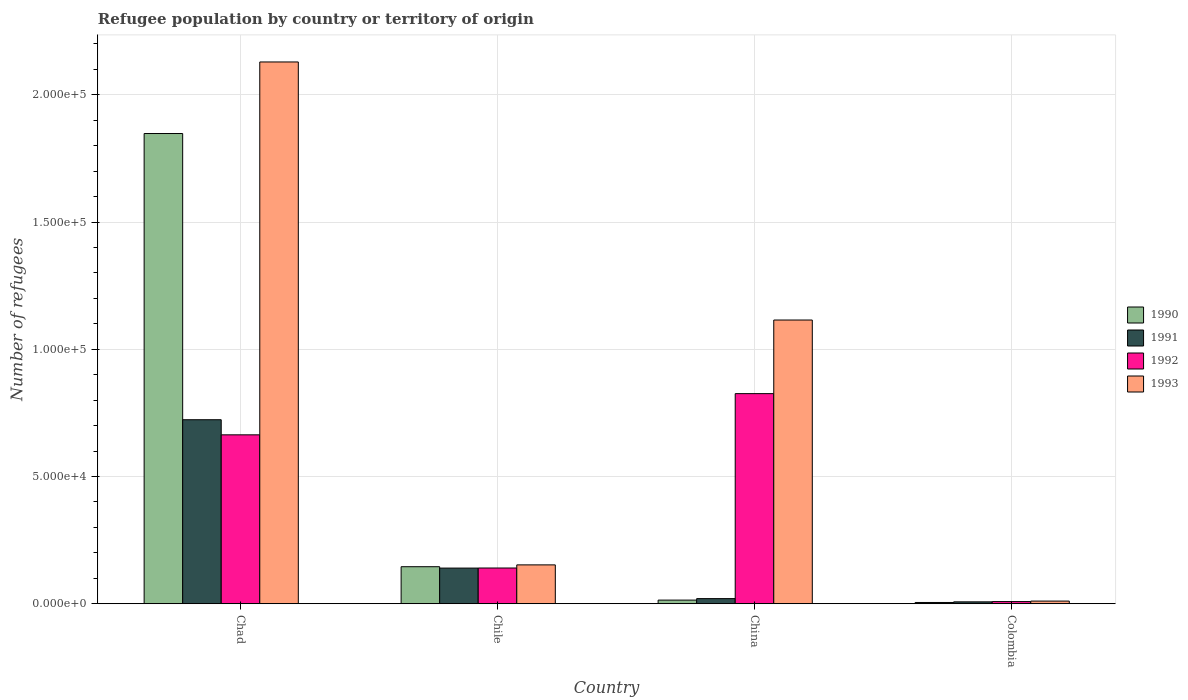How many bars are there on the 3rd tick from the left?
Ensure brevity in your answer.  4. How many bars are there on the 1st tick from the right?
Provide a succinct answer. 4. In how many cases, is the number of bars for a given country not equal to the number of legend labels?
Give a very brief answer. 0. What is the number of refugees in 1992 in Chile?
Provide a short and direct response. 1.40e+04. Across all countries, what is the maximum number of refugees in 1993?
Your answer should be very brief. 2.13e+05. Across all countries, what is the minimum number of refugees in 1992?
Keep it short and to the point. 843. In which country was the number of refugees in 1993 maximum?
Offer a terse response. Chad. In which country was the number of refugees in 1992 minimum?
Provide a succinct answer. Colombia. What is the total number of refugees in 1992 in the graph?
Offer a very short reply. 1.64e+05. What is the difference between the number of refugees in 1992 in China and that in Colombia?
Make the answer very short. 8.17e+04. What is the difference between the number of refugees in 1990 in China and the number of refugees in 1993 in Chad?
Give a very brief answer. -2.12e+05. What is the average number of refugees in 1992 per country?
Offer a terse response. 4.10e+04. What is the difference between the number of refugees of/in 1992 and number of refugees of/in 1991 in Chile?
Make the answer very short. 36. What is the ratio of the number of refugees in 1993 in China to that in Colombia?
Your answer should be very brief. 107.01. What is the difference between the highest and the second highest number of refugees in 1991?
Make the answer very short. 1.20e+04. What is the difference between the highest and the lowest number of refugees in 1992?
Ensure brevity in your answer.  8.17e+04. In how many countries, is the number of refugees in 1993 greater than the average number of refugees in 1993 taken over all countries?
Your answer should be compact. 2. How many countries are there in the graph?
Offer a terse response. 4. Does the graph contain grids?
Your answer should be compact. Yes. What is the title of the graph?
Keep it short and to the point. Refugee population by country or territory of origin. Does "1973" appear as one of the legend labels in the graph?
Offer a terse response. No. What is the label or title of the X-axis?
Your response must be concise. Country. What is the label or title of the Y-axis?
Keep it short and to the point. Number of refugees. What is the Number of refugees in 1990 in Chad?
Your answer should be compact. 1.85e+05. What is the Number of refugees in 1991 in Chad?
Offer a very short reply. 7.23e+04. What is the Number of refugees of 1992 in Chad?
Make the answer very short. 6.64e+04. What is the Number of refugees in 1993 in Chad?
Make the answer very short. 2.13e+05. What is the Number of refugees of 1990 in Chile?
Keep it short and to the point. 1.45e+04. What is the Number of refugees of 1991 in Chile?
Offer a terse response. 1.40e+04. What is the Number of refugees in 1992 in Chile?
Provide a short and direct response. 1.40e+04. What is the Number of refugees of 1993 in Chile?
Keep it short and to the point. 1.53e+04. What is the Number of refugees of 1990 in China?
Your answer should be compact. 1426. What is the Number of refugees of 1991 in China?
Keep it short and to the point. 2011. What is the Number of refugees of 1992 in China?
Your response must be concise. 8.26e+04. What is the Number of refugees of 1993 in China?
Your answer should be very brief. 1.12e+05. What is the Number of refugees of 1990 in Colombia?
Make the answer very short. 494. What is the Number of refugees in 1991 in Colombia?
Offer a very short reply. 740. What is the Number of refugees of 1992 in Colombia?
Provide a succinct answer. 843. What is the Number of refugees of 1993 in Colombia?
Make the answer very short. 1042. Across all countries, what is the maximum Number of refugees in 1990?
Provide a short and direct response. 1.85e+05. Across all countries, what is the maximum Number of refugees in 1991?
Offer a terse response. 7.23e+04. Across all countries, what is the maximum Number of refugees in 1992?
Your answer should be compact. 8.26e+04. Across all countries, what is the maximum Number of refugees in 1993?
Your answer should be compact. 2.13e+05. Across all countries, what is the minimum Number of refugees of 1990?
Keep it short and to the point. 494. Across all countries, what is the minimum Number of refugees of 1991?
Offer a terse response. 740. Across all countries, what is the minimum Number of refugees of 1992?
Your answer should be compact. 843. Across all countries, what is the minimum Number of refugees in 1993?
Your response must be concise. 1042. What is the total Number of refugees in 1990 in the graph?
Offer a very short reply. 2.01e+05. What is the total Number of refugees of 1991 in the graph?
Give a very brief answer. 8.91e+04. What is the total Number of refugees of 1992 in the graph?
Offer a very short reply. 1.64e+05. What is the total Number of refugees of 1993 in the graph?
Your answer should be compact. 3.41e+05. What is the difference between the Number of refugees in 1990 in Chad and that in Chile?
Your answer should be compact. 1.70e+05. What is the difference between the Number of refugees in 1991 in Chad and that in Chile?
Make the answer very short. 5.83e+04. What is the difference between the Number of refugees of 1992 in Chad and that in Chile?
Make the answer very short. 5.23e+04. What is the difference between the Number of refugees of 1993 in Chad and that in Chile?
Provide a succinct answer. 1.98e+05. What is the difference between the Number of refugees of 1990 in Chad and that in China?
Your response must be concise. 1.83e+05. What is the difference between the Number of refugees in 1991 in Chad and that in China?
Your answer should be compact. 7.03e+04. What is the difference between the Number of refugees of 1992 in Chad and that in China?
Make the answer very short. -1.62e+04. What is the difference between the Number of refugees of 1993 in Chad and that in China?
Offer a terse response. 1.01e+05. What is the difference between the Number of refugees in 1990 in Chad and that in Colombia?
Offer a very short reply. 1.84e+05. What is the difference between the Number of refugees of 1991 in Chad and that in Colombia?
Provide a succinct answer. 7.16e+04. What is the difference between the Number of refugees in 1992 in Chad and that in Colombia?
Offer a very short reply. 6.55e+04. What is the difference between the Number of refugees of 1993 in Chad and that in Colombia?
Keep it short and to the point. 2.12e+05. What is the difference between the Number of refugees in 1990 in Chile and that in China?
Provide a short and direct response. 1.31e+04. What is the difference between the Number of refugees of 1991 in Chile and that in China?
Offer a terse response. 1.20e+04. What is the difference between the Number of refugees of 1992 in Chile and that in China?
Provide a succinct answer. -6.85e+04. What is the difference between the Number of refugees in 1993 in Chile and that in China?
Ensure brevity in your answer.  -9.62e+04. What is the difference between the Number of refugees of 1990 in Chile and that in Colombia?
Provide a short and direct response. 1.41e+04. What is the difference between the Number of refugees in 1991 in Chile and that in Colombia?
Make the answer very short. 1.33e+04. What is the difference between the Number of refugees of 1992 in Chile and that in Colombia?
Provide a succinct answer. 1.32e+04. What is the difference between the Number of refugees in 1993 in Chile and that in Colombia?
Provide a short and direct response. 1.42e+04. What is the difference between the Number of refugees in 1990 in China and that in Colombia?
Offer a terse response. 932. What is the difference between the Number of refugees in 1991 in China and that in Colombia?
Offer a terse response. 1271. What is the difference between the Number of refugees of 1992 in China and that in Colombia?
Your answer should be compact. 8.17e+04. What is the difference between the Number of refugees of 1993 in China and that in Colombia?
Ensure brevity in your answer.  1.10e+05. What is the difference between the Number of refugees in 1990 in Chad and the Number of refugees in 1991 in Chile?
Give a very brief answer. 1.71e+05. What is the difference between the Number of refugees in 1990 in Chad and the Number of refugees in 1992 in Chile?
Your response must be concise. 1.71e+05. What is the difference between the Number of refugees in 1990 in Chad and the Number of refugees in 1993 in Chile?
Make the answer very short. 1.70e+05. What is the difference between the Number of refugees of 1991 in Chad and the Number of refugees of 1992 in Chile?
Your answer should be compact. 5.83e+04. What is the difference between the Number of refugees of 1991 in Chad and the Number of refugees of 1993 in Chile?
Provide a succinct answer. 5.71e+04. What is the difference between the Number of refugees of 1992 in Chad and the Number of refugees of 1993 in Chile?
Ensure brevity in your answer.  5.11e+04. What is the difference between the Number of refugees in 1990 in Chad and the Number of refugees in 1991 in China?
Offer a very short reply. 1.83e+05. What is the difference between the Number of refugees in 1990 in Chad and the Number of refugees in 1992 in China?
Offer a terse response. 1.02e+05. What is the difference between the Number of refugees in 1990 in Chad and the Number of refugees in 1993 in China?
Your answer should be compact. 7.33e+04. What is the difference between the Number of refugees of 1991 in Chad and the Number of refugees of 1992 in China?
Make the answer very short. -1.03e+04. What is the difference between the Number of refugees in 1991 in Chad and the Number of refugees in 1993 in China?
Give a very brief answer. -3.92e+04. What is the difference between the Number of refugees in 1992 in Chad and the Number of refugees in 1993 in China?
Your answer should be very brief. -4.51e+04. What is the difference between the Number of refugees of 1990 in Chad and the Number of refugees of 1991 in Colombia?
Provide a succinct answer. 1.84e+05. What is the difference between the Number of refugees in 1990 in Chad and the Number of refugees in 1992 in Colombia?
Your answer should be compact. 1.84e+05. What is the difference between the Number of refugees of 1990 in Chad and the Number of refugees of 1993 in Colombia?
Your response must be concise. 1.84e+05. What is the difference between the Number of refugees in 1991 in Chad and the Number of refugees in 1992 in Colombia?
Your answer should be very brief. 7.15e+04. What is the difference between the Number of refugees of 1991 in Chad and the Number of refugees of 1993 in Colombia?
Provide a short and direct response. 7.13e+04. What is the difference between the Number of refugees in 1992 in Chad and the Number of refugees in 1993 in Colombia?
Your response must be concise. 6.53e+04. What is the difference between the Number of refugees in 1990 in Chile and the Number of refugees in 1991 in China?
Provide a succinct answer. 1.25e+04. What is the difference between the Number of refugees in 1990 in Chile and the Number of refugees in 1992 in China?
Provide a succinct answer. -6.80e+04. What is the difference between the Number of refugees in 1990 in Chile and the Number of refugees in 1993 in China?
Provide a succinct answer. -9.70e+04. What is the difference between the Number of refugees in 1991 in Chile and the Number of refugees in 1992 in China?
Make the answer very short. -6.86e+04. What is the difference between the Number of refugees in 1991 in Chile and the Number of refugees in 1993 in China?
Offer a very short reply. -9.75e+04. What is the difference between the Number of refugees of 1992 in Chile and the Number of refugees of 1993 in China?
Make the answer very short. -9.75e+04. What is the difference between the Number of refugees in 1990 in Chile and the Number of refugees in 1991 in Colombia?
Provide a succinct answer. 1.38e+04. What is the difference between the Number of refugees in 1990 in Chile and the Number of refugees in 1992 in Colombia?
Your answer should be very brief. 1.37e+04. What is the difference between the Number of refugees of 1990 in Chile and the Number of refugees of 1993 in Colombia?
Provide a succinct answer. 1.35e+04. What is the difference between the Number of refugees of 1991 in Chile and the Number of refugees of 1992 in Colombia?
Give a very brief answer. 1.32e+04. What is the difference between the Number of refugees of 1991 in Chile and the Number of refugees of 1993 in Colombia?
Your answer should be very brief. 1.30e+04. What is the difference between the Number of refugees in 1992 in Chile and the Number of refugees in 1993 in Colombia?
Provide a short and direct response. 1.30e+04. What is the difference between the Number of refugees of 1990 in China and the Number of refugees of 1991 in Colombia?
Ensure brevity in your answer.  686. What is the difference between the Number of refugees in 1990 in China and the Number of refugees in 1992 in Colombia?
Make the answer very short. 583. What is the difference between the Number of refugees in 1990 in China and the Number of refugees in 1993 in Colombia?
Your response must be concise. 384. What is the difference between the Number of refugees of 1991 in China and the Number of refugees of 1992 in Colombia?
Offer a very short reply. 1168. What is the difference between the Number of refugees in 1991 in China and the Number of refugees in 1993 in Colombia?
Keep it short and to the point. 969. What is the difference between the Number of refugees of 1992 in China and the Number of refugees of 1993 in Colombia?
Your answer should be compact. 8.15e+04. What is the average Number of refugees of 1990 per country?
Give a very brief answer. 5.03e+04. What is the average Number of refugees of 1991 per country?
Keep it short and to the point. 2.23e+04. What is the average Number of refugees in 1992 per country?
Your response must be concise. 4.10e+04. What is the average Number of refugees in 1993 per country?
Offer a very short reply. 8.52e+04. What is the difference between the Number of refugees in 1990 and Number of refugees in 1991 in Chad?
Provide a succinct answer. 1.12e+05. What is the difference between the Number of refugees in 1990 and Number of refugees in 1992 in Chad?
Your response must be concise. 1.18e+05. What is the difference between the Number of refugees of 1990 and Number of refugees of 1993 in Chad?
Give a very brief answer. -2.81e+04. What is the difference between the Number of refugees of 1991 and Number of refugees of 1992 in Chad?
Your response must be concise. 5938. What is the difference between the Number of refugees in 1991 and Number of refugees in 1993 in Chad?
Ensure brevity in your answer.  -1.41e+05. What is the difference between the Number of refugees in 1992 and Number of refugees in 1993 in Chad?
Offer a very short reply. -1.47e+05. What is the difference between the Number of refugees of 1990 and Number of refugees of 1991 in Chile?
Make the answer very short. 541. What is the difference between the Number of refugees of 1990 and Number of refugees of 1992 in Chile?
Provide a short and direct response. 505. What is the difference between the Number of refugees of 1990 and Number of refugees of 1993 in Chile?
Offer a very short reply. -719. What is the difference between the Number of refugees in 1991 and Number of refugees in 1992 in Chile?
Your answer should be very brief. -36. What is the difference between the Number of refugees of 1991 and Number of refugees of 1993 in Chile?
Provide a short and direct response. -1260. What is the difference between the Number of refugees in 1992 and Number of refugees in 1993 in Chile?
Provide a short and direct response. -1224. What is the difference between the Number of refugees of 1990 and Number of refugees of 1991 in China?
Offer a very short reply. -585. What is the difference between the Number of refugees of 1990 and Number of refugees of 1992 in China?
Make the answer very short. -8.12e+04. What is the difference between the Number of refugees of 1990 and Number of refugees of 1993 in China?
Offer a very short reply. -1.10e+05. What is the difference between the Number of refugees in 1991 and Number of refugees in 1992 in China?
Provide a short and direct response. -8.06e+04. What is the difference between the Number of refugees in 1991 and Number of refugees in 1993 in China?
Provide a short and direct response. -1.09e+05. What is the difference between the Number of refugees in 1992 and Number of refugees in 1993 in China?
Keep it short and to the point. -2.89e+04. What is the difference between the Number of refugees in 1990 and Number of refugees in 1991 in Colombia?
Ensure brevity in your answer.  -246. What is the difference between the Number of refugees in 1990 and Number of refugees in 1992 in Colombia?
Your response must be concise. -349. What is the difference between the Number of refugees in 1990 and Number of refugees in 1993 in Colombia?
Give a very brief answer. -548. What is the difference between the Number of refugees of 1991 and Number of refugees of 1992 in Colombia?
Keep it short and to the point. -103. What is the difference between the Number of refugees in 1991 and Number of refugees in 1993 in Colombia?
Give a very brief answer. -302. What is the difference between the Number of refugees of 1992 and Number of refugees of 1993 in Colombia?
Give a very brief answer. -199. What is the ratio of the Number of refugees of 1990 in Chad to that in Chile?
Offer a very short reply. 12.7. What is the ratio of the Number of refugees in 1991 in Chad to that in Chile?
Your answer should be compact. 5.16. What is the ratio of the Number of refugees of 1992 in Chad to that in Chile?
Your answer should be compact. 4.73. What is the ratio of the Number of refugees of 1993 in Chad to that in Chile?
Provide a succinct answer. 13.95. What is the ratio of the Number of refugees in 1990 in Chad to that in China?
Your answer should be very brief. 129.6. What is the ratio of the Number of refugees in 1991 in Chad to that in China?
Offer a very short reply. 35.96. What is the ratio of the Number of refugees in 1992 in Chad to that in China?
Keep it short and to the point. 0.8. What is the ratio of the Number of refugees in 1993 in Chad to that in China?
Make the answer very short. 1.91. What is the ratio of the Number of refugees in 1990 in Chad to that in Colombia?
Offer a terse response. 374.1. What is the ratio of the Number of refugees in 1991 in Chad to that in Colombia?
Offer a very short reply. 97.73. What is the ratio of the Number of refugees of 1992 in Chad to that in Colombia?
Ensure brevity in your answer.  78.74. What is the ratio of the Number of refugees in 1993 in Chad to that in Colombia?
Offer a very short reply. 204.35. What is the ratio of the Number of refugees of 1990 in Chile to that in China?
Provide a short and direct response. 10.2. What is the ratio of the Number of refugees in 1991 in Chile to that in China?
Make the answer very short. 6.97. What is the ratio of the Number of refugees of 1992 in Chile to that in China?
Offer a terse response. 0.17. What is the ratio of the Number of refugees in 1993 in Chile to that in China?
Your response must be concise. 0.14. What is the ratio of the Number of refugees in 1990 in Chile to that in Colombia?
Provide a short and direct response. 29.45. What is the ratio of the Number of refugees in 1991 in Chile to that in Colombia?
Your answer should be compact. 18.93. What is the ratio of the Number of refugees in 1992 in Chile to that in Colombia?
Your answer should be very brief. 16.66. What is the ratio of the Number of refugees in 1993 in Chile to that in Colombia?
Ensure brevity in your answer.  14.65. What is the ratio of the Number of refugees in 1990 in China to that in Colombia?
Your response must be concise. 2.89. What is the ratio of the Number of refugees of 1991 in China to that in Colombia?
Ensure brevity in your answer.  2.72. What is the ratio of the Number of refugees of 1992 in China to that in Colombia?
Keep it short and to the point. 97.95. What is the ratio of the Number of refugees in 1993 in China to that in Colombia?
Give a very brief answer. 107.01. What is the difference between the highest and the second highest Number of refugees in 1990?
Ensure brevity in your answer.  1.70e+05. What is the difference between the highest and the second highest Number of refugees of 1991?
Your response must be concise. 5.83e+04. What is the difference between the highest and the second highest Number of refugees in 1992?
Make the answer very short. 1.62e+04. What is the difference between the highest and the second highest Number of refugees of 1993?
Ensure brevity in your answer.  1.01e+05. What is the difference between the highest and the lowest Number of refugees of 1990?
Provide a succinct answer. 1.84e+05. What is the difference between the highest and the lowest Number of refugees in 1991?
Keep it short and to the point. 7.16e+04. What is the difference between the highest and the lowest Number of refugees of 1992?
Your answer should be compact. 8.17e+04. What is the difference between the highest and the lowest Number of refugees in 1993?
Your answer should be very brief. 2.12e+05. 